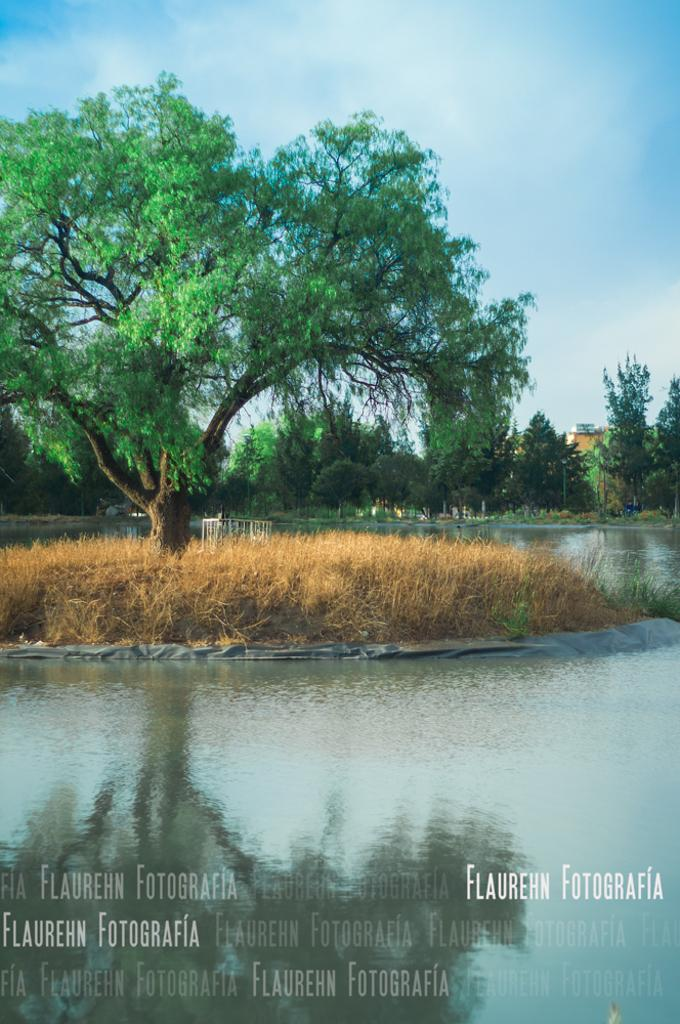What type of natural environment is depicted in the image? The image contains water, grass, and trees, which are elements of a natural environment. What can be seen in the background of the image? There is a wall and sky visible in the background of the image. Is there any text present in the image? Yes, there is text at the bottom of the image. What type of pest can be seen crawling on the quartz in the image? There is no pest or quartz present in the image. 